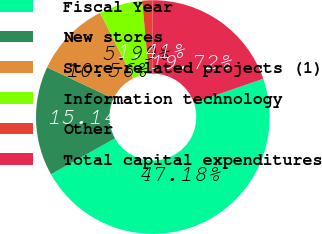Convert chart to OTSL. <chart><loc_0><loc_0><loc_500><loc_500><pie_chart><fcel>Fiscal Year<fcel>New stores<fcel>Store-related projects (1)<fcel>Information technology<fcel>Other<fcel>Total capital expenditures<nl><fcel>47.18%<fcel>15.14%<fcel>10.56%<fcel>5.99%<fcel>1.41%<fcel>19.72%<nl></chart> 